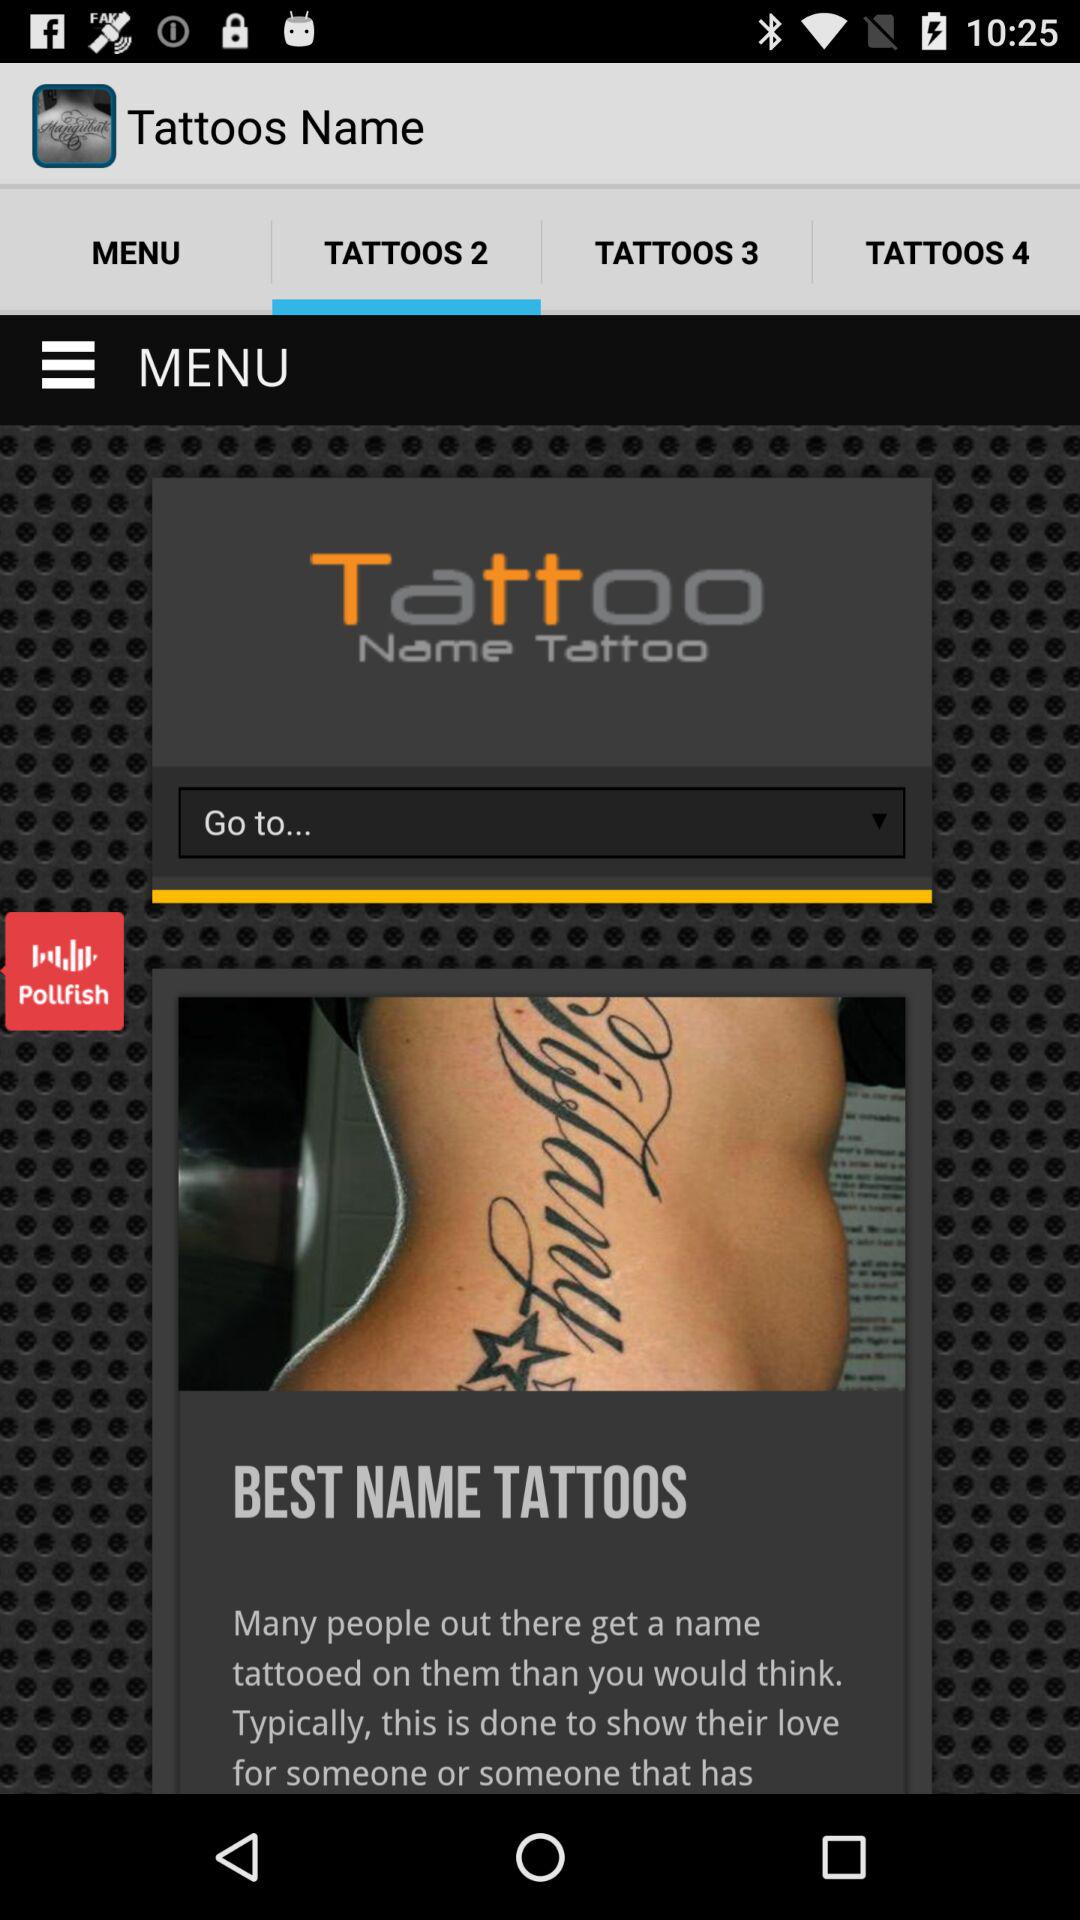What tab is selected? The selected tab is "TATTOOS 2". 